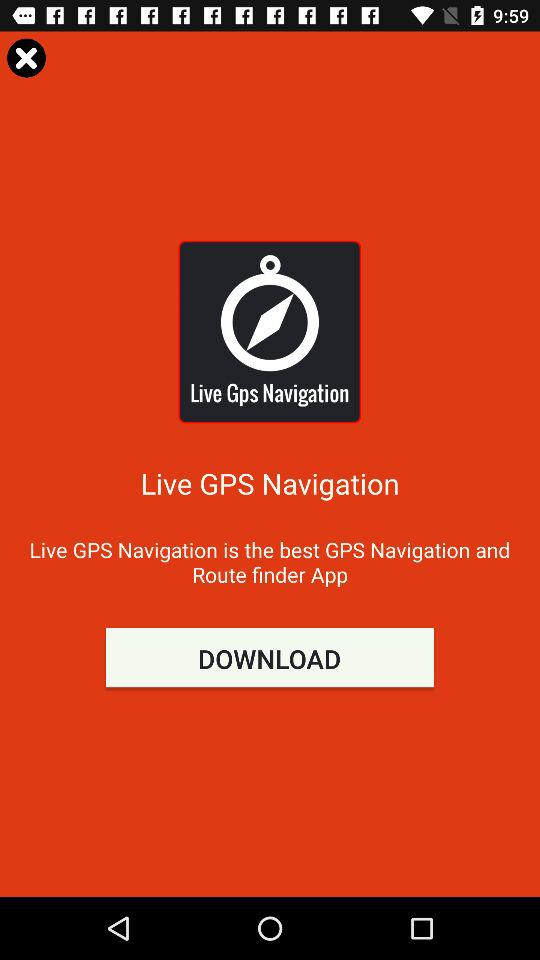What is the application name? The application name is "Live GPS Navigation". 